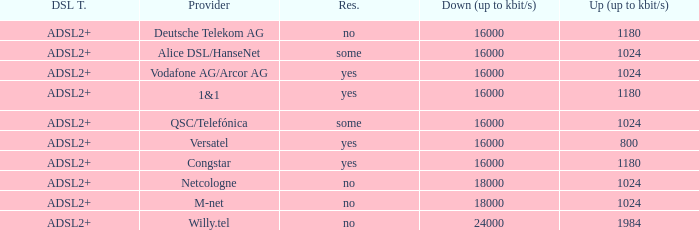What is download bandwith where the provider is deutsche telekom ag? 16000.0. 